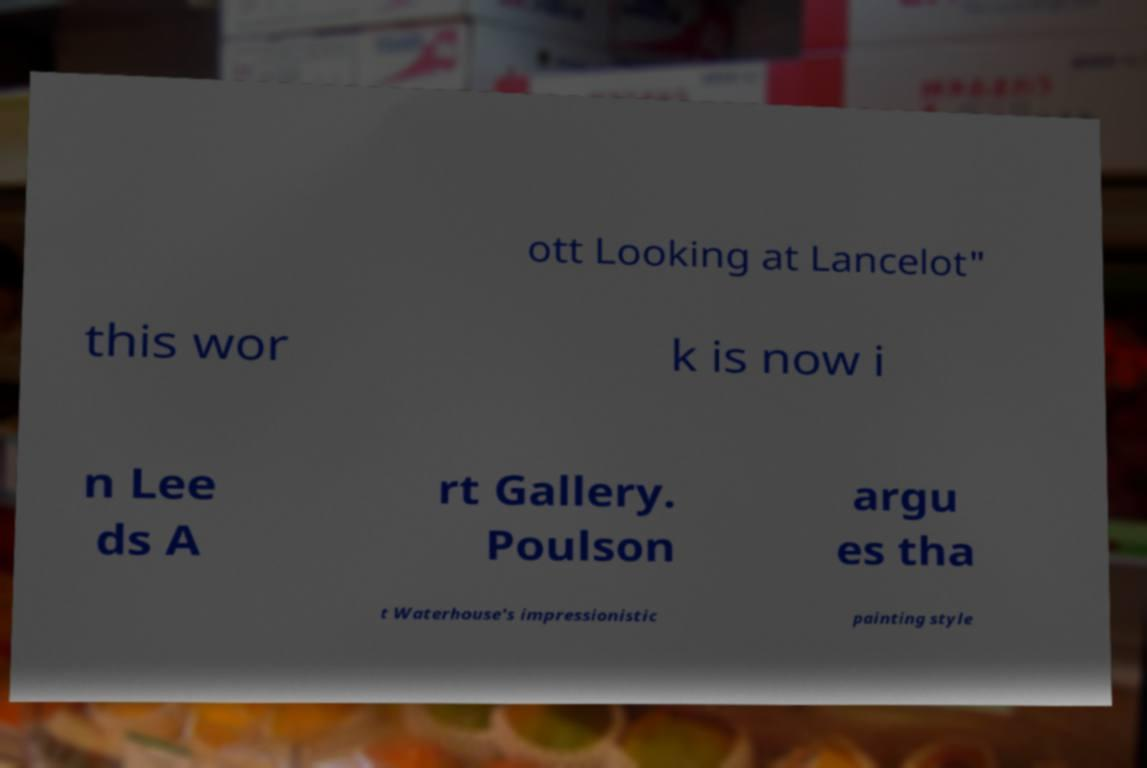Could you assist in decoding the text presented in this image and type it out clearly? ott Looking at Lancelot" this wor k is now i n Lee ds A rt Gallery. Poulson argu es tha t Waterhouse's impressionistic painting style 